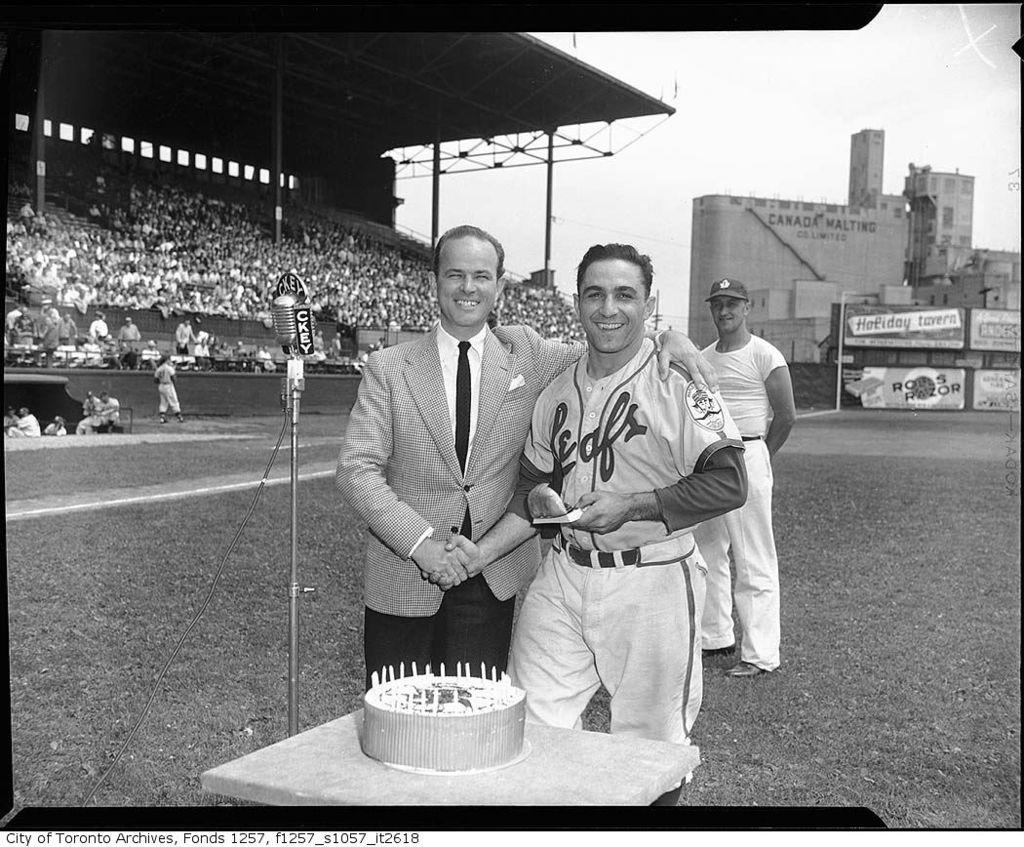<image>
Provide a brief description of the given image. a baseball player in a Leafs jersey shakes hands with someone else in front of a cake 